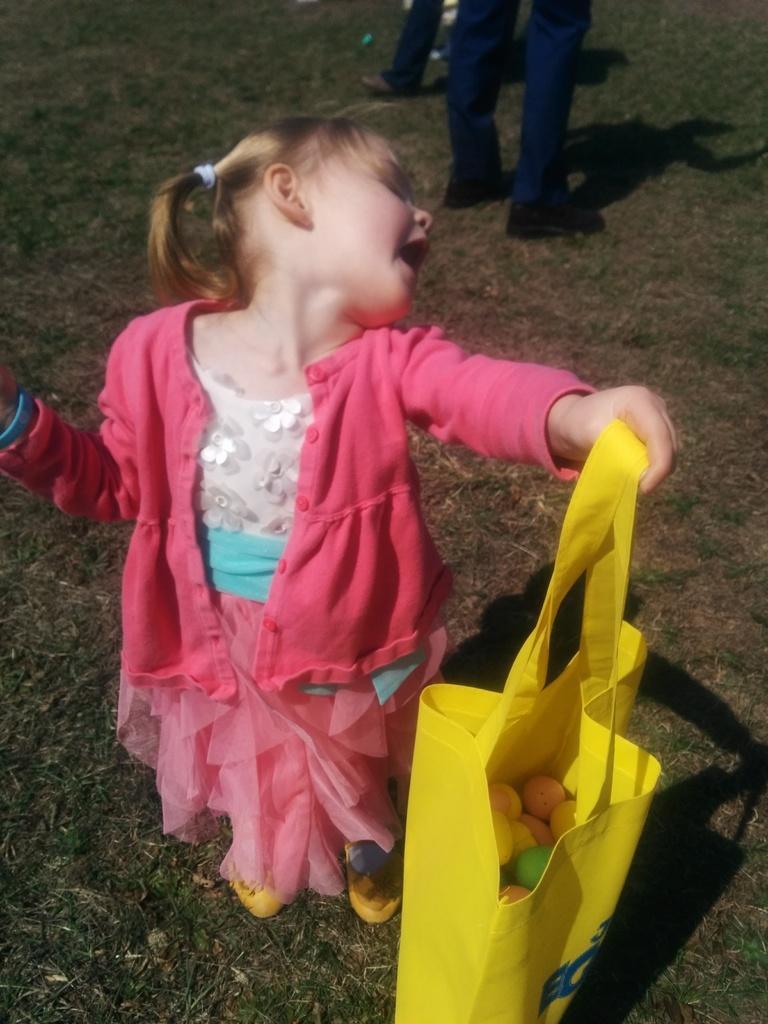How would you summarize this image in a sentence or two? In this image we can see a girl. A girl is held a bag in which few objects are there. There is a grassy land in the image. There are two persons are standing beside a girl. 